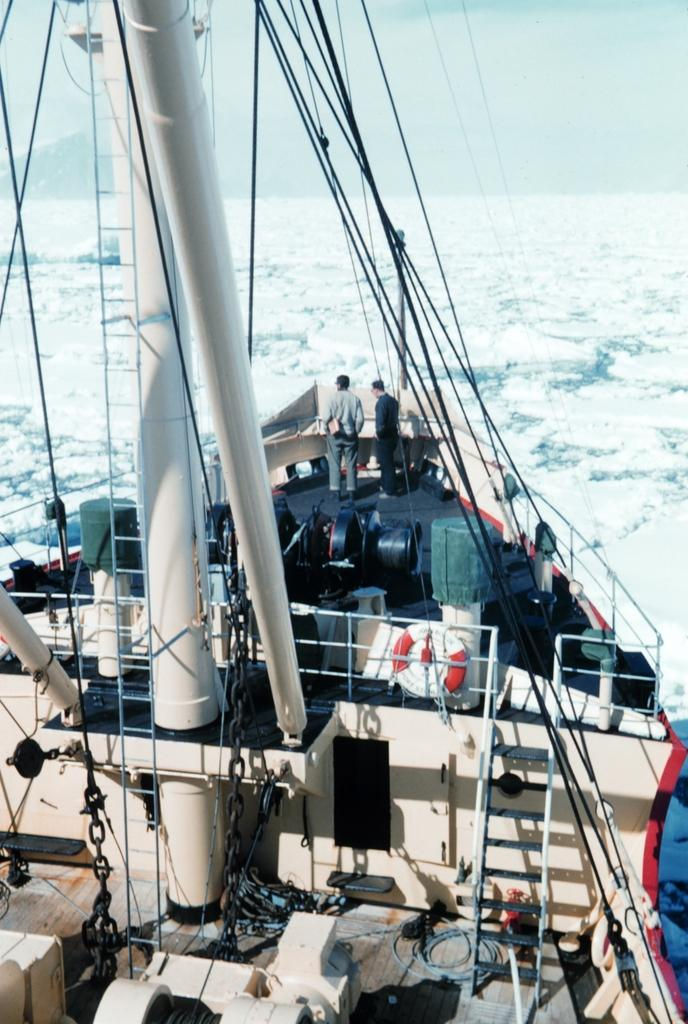What is the main object in the image? There is a sail in the image. Who or what is on the sail? There are two persons on the sail. What is the condition of the surrounding area? The surrounding region is covered with snow. What can be seen on the sail besides the persons? There are many objects on the sail. What type of reaction can be observed from the mind of the person on the left side of the sail? There is no indication of a person's mind or reaction in the image, as it only shows a sail with two persons and objects on it. 